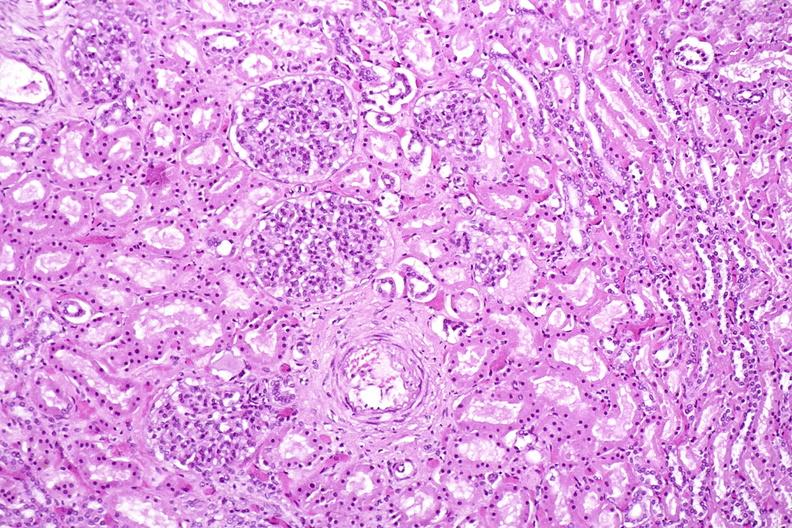what does this image show?
Answer the question using a single word or phrase. Kidney 